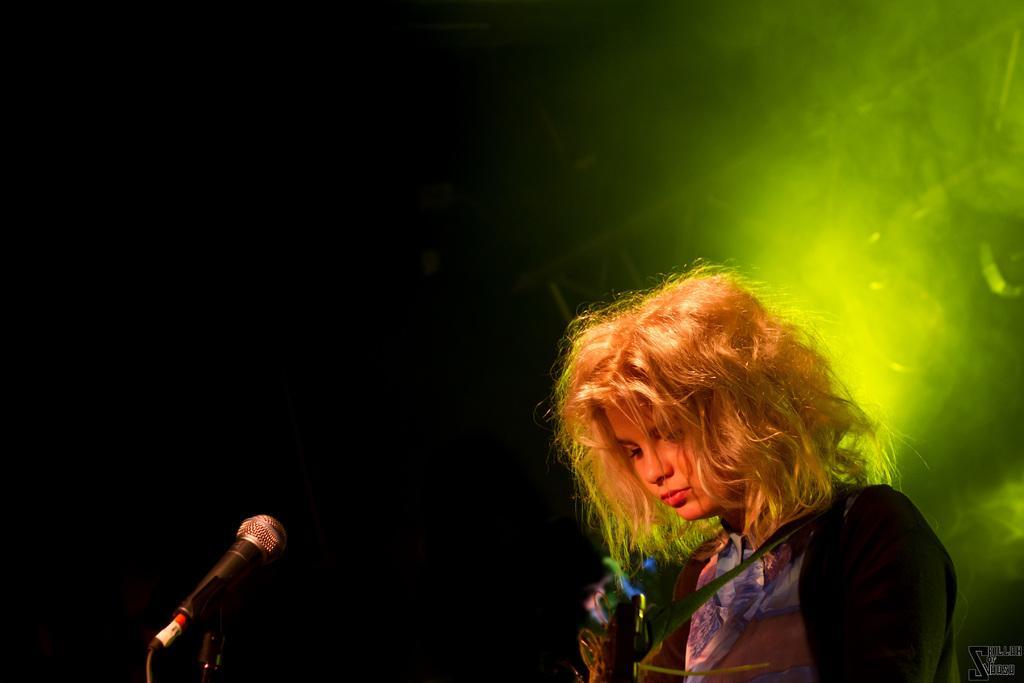Describe this image in one or two sentences. On the right side of the image there is a girl standing. She is wearing a blue dress. There is a mic placed before her. In the background there is a light. 